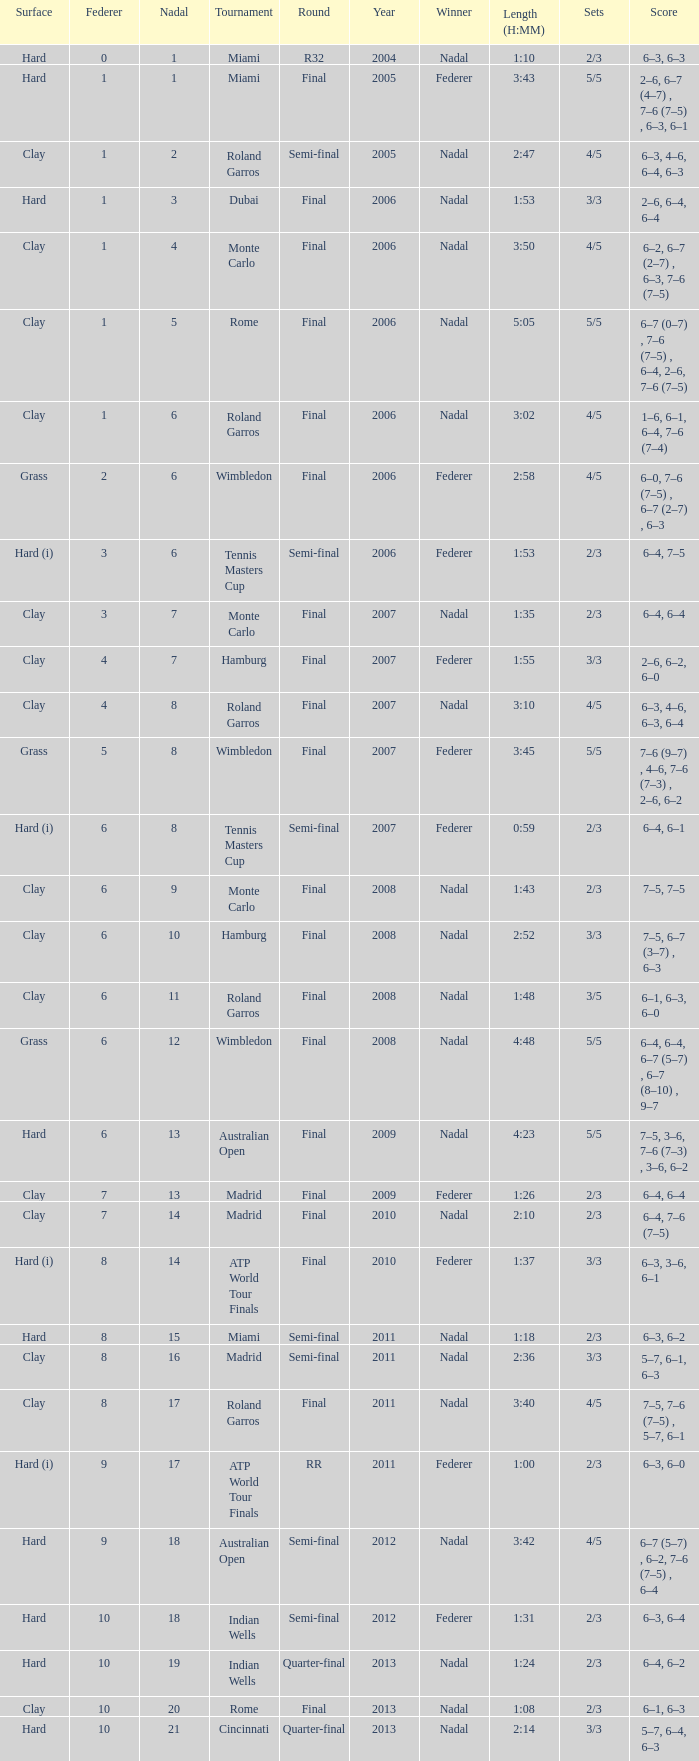What was the nadal in Miami in the final round? 1.0. 